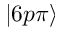Convert formula to latex. <formula><loc_0><loc_0><loc_500><loc_500>| 6 p \pi \rangle</formula> 